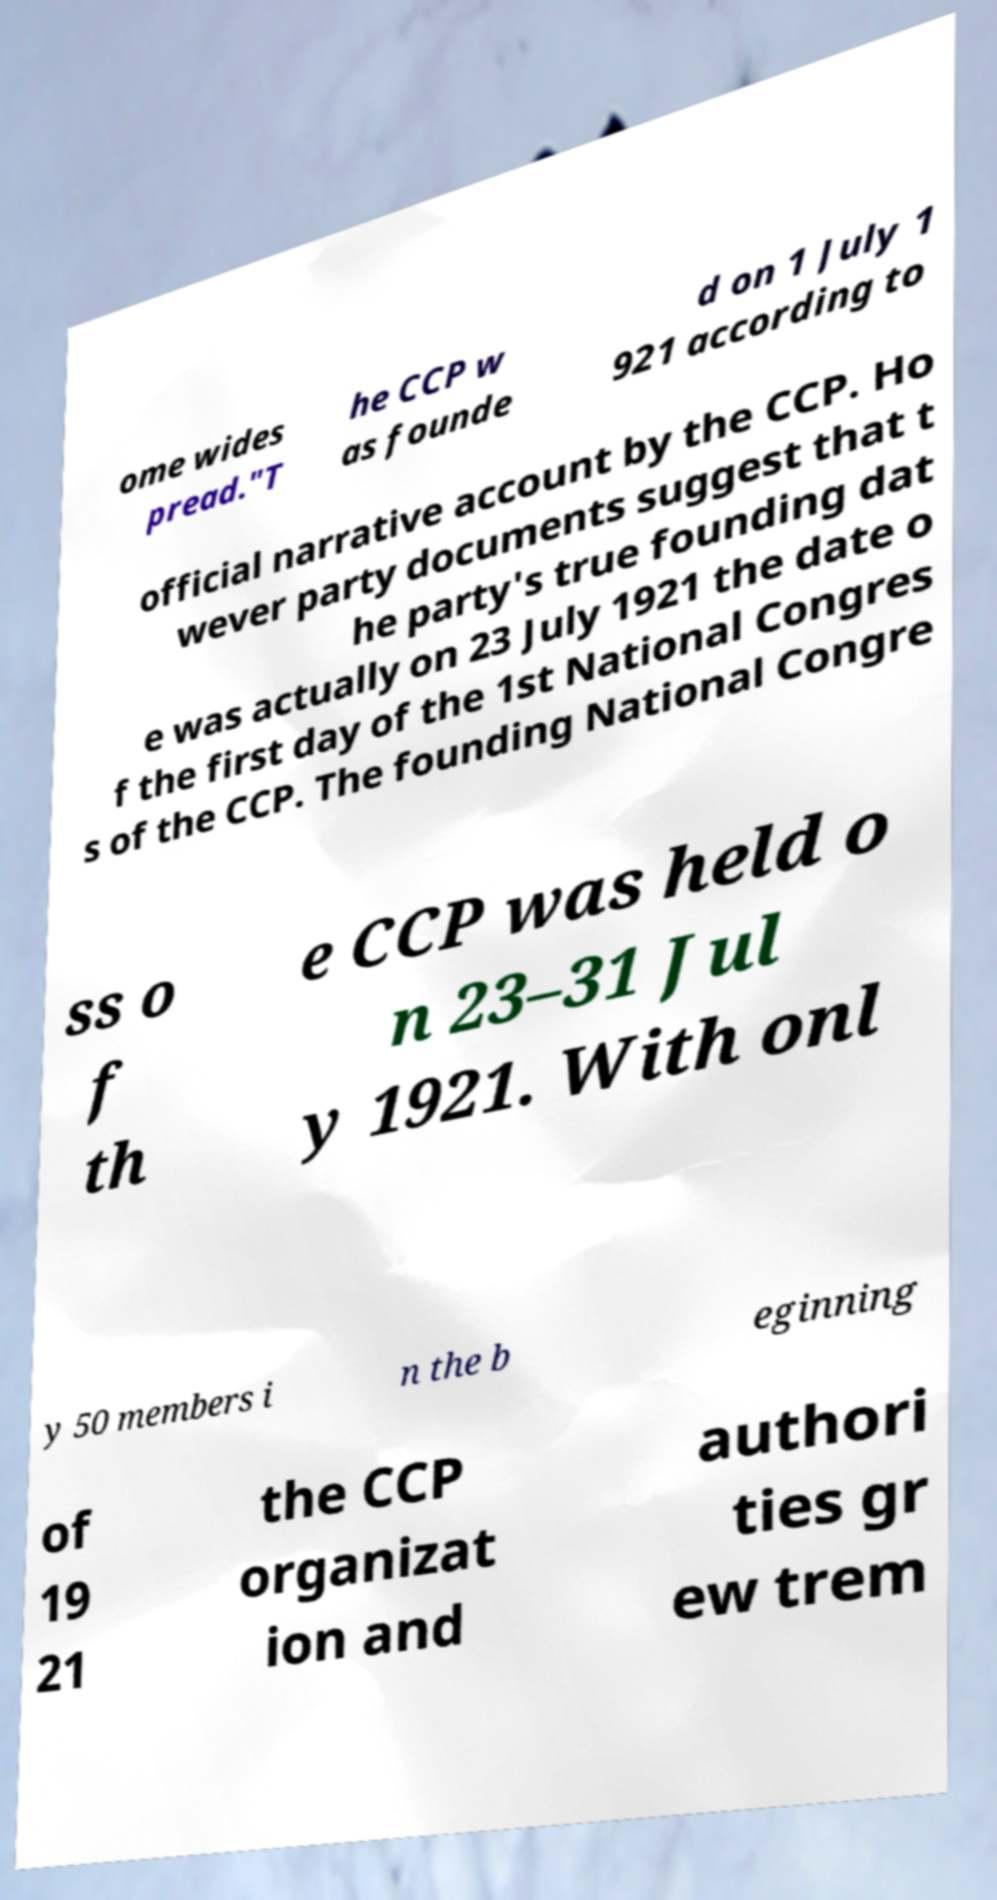Please identify and transcribe the text found in this image. ome wides pread."T he CCP w as founde d on 1 July 1 921 according to official narrative account by the CCP. Ho wever party documents suggest that t he party's true founding dat e was actually on 23 July 1921 the date o f the first day of the 1st National Congres s of the CCP. The founding National Congre ss o f th e CCP was held o n 23–31 Jul y 1921. With onl y 50 members i n the b eginning of 19 21 the CCP organizat ion and authori ties gr ew trem 